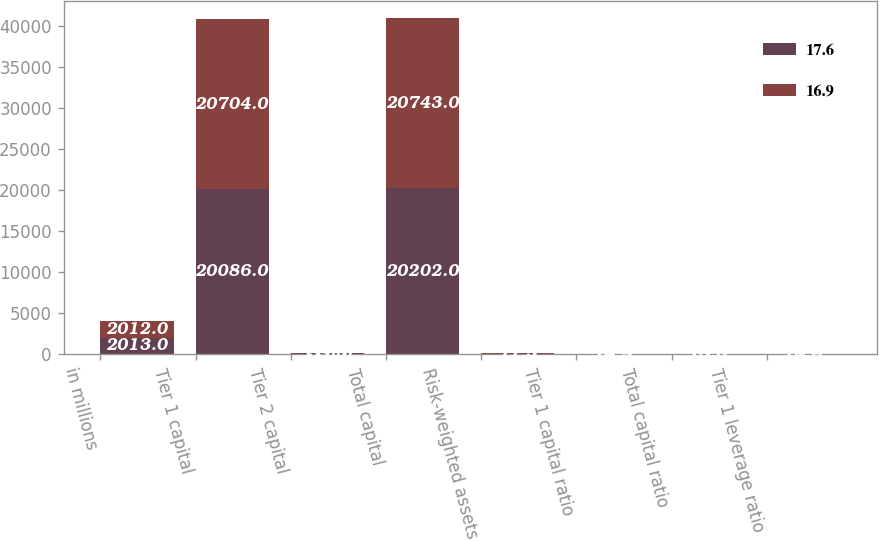Convert chart to OTSL. <chart><loc_0><loc_0><loc_500><loc_500><stacked_bar_chart><ecel><fcel>in millions<fcel>Tier 1 capital<fcel>Tier 2 capital<fcel>Total capital<fcel>Risk-weighted assets<fcel>Tier 1 capital ratio<fcel>Total capital ratio<fcel>Tier 1 leverage ratio<nl><fcel>17.6<fcel>2013<fcel>20086<fcel>116<fcel>20202<fcel>77.5<fcel>14.9<fcel>15<fcel>16.9<nl><fcel>16.9<fcel>2012<fcel>20704<fcel>39<fcel>20743<fcel>77.5<fcel>18.9<fcel>18.9<fcel>17.6<nl></chart> 